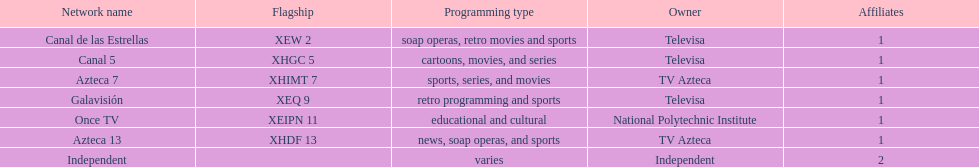What is the difference between the number of affiliates galavision has and the number of affiliates azteca 13 has? 0. 